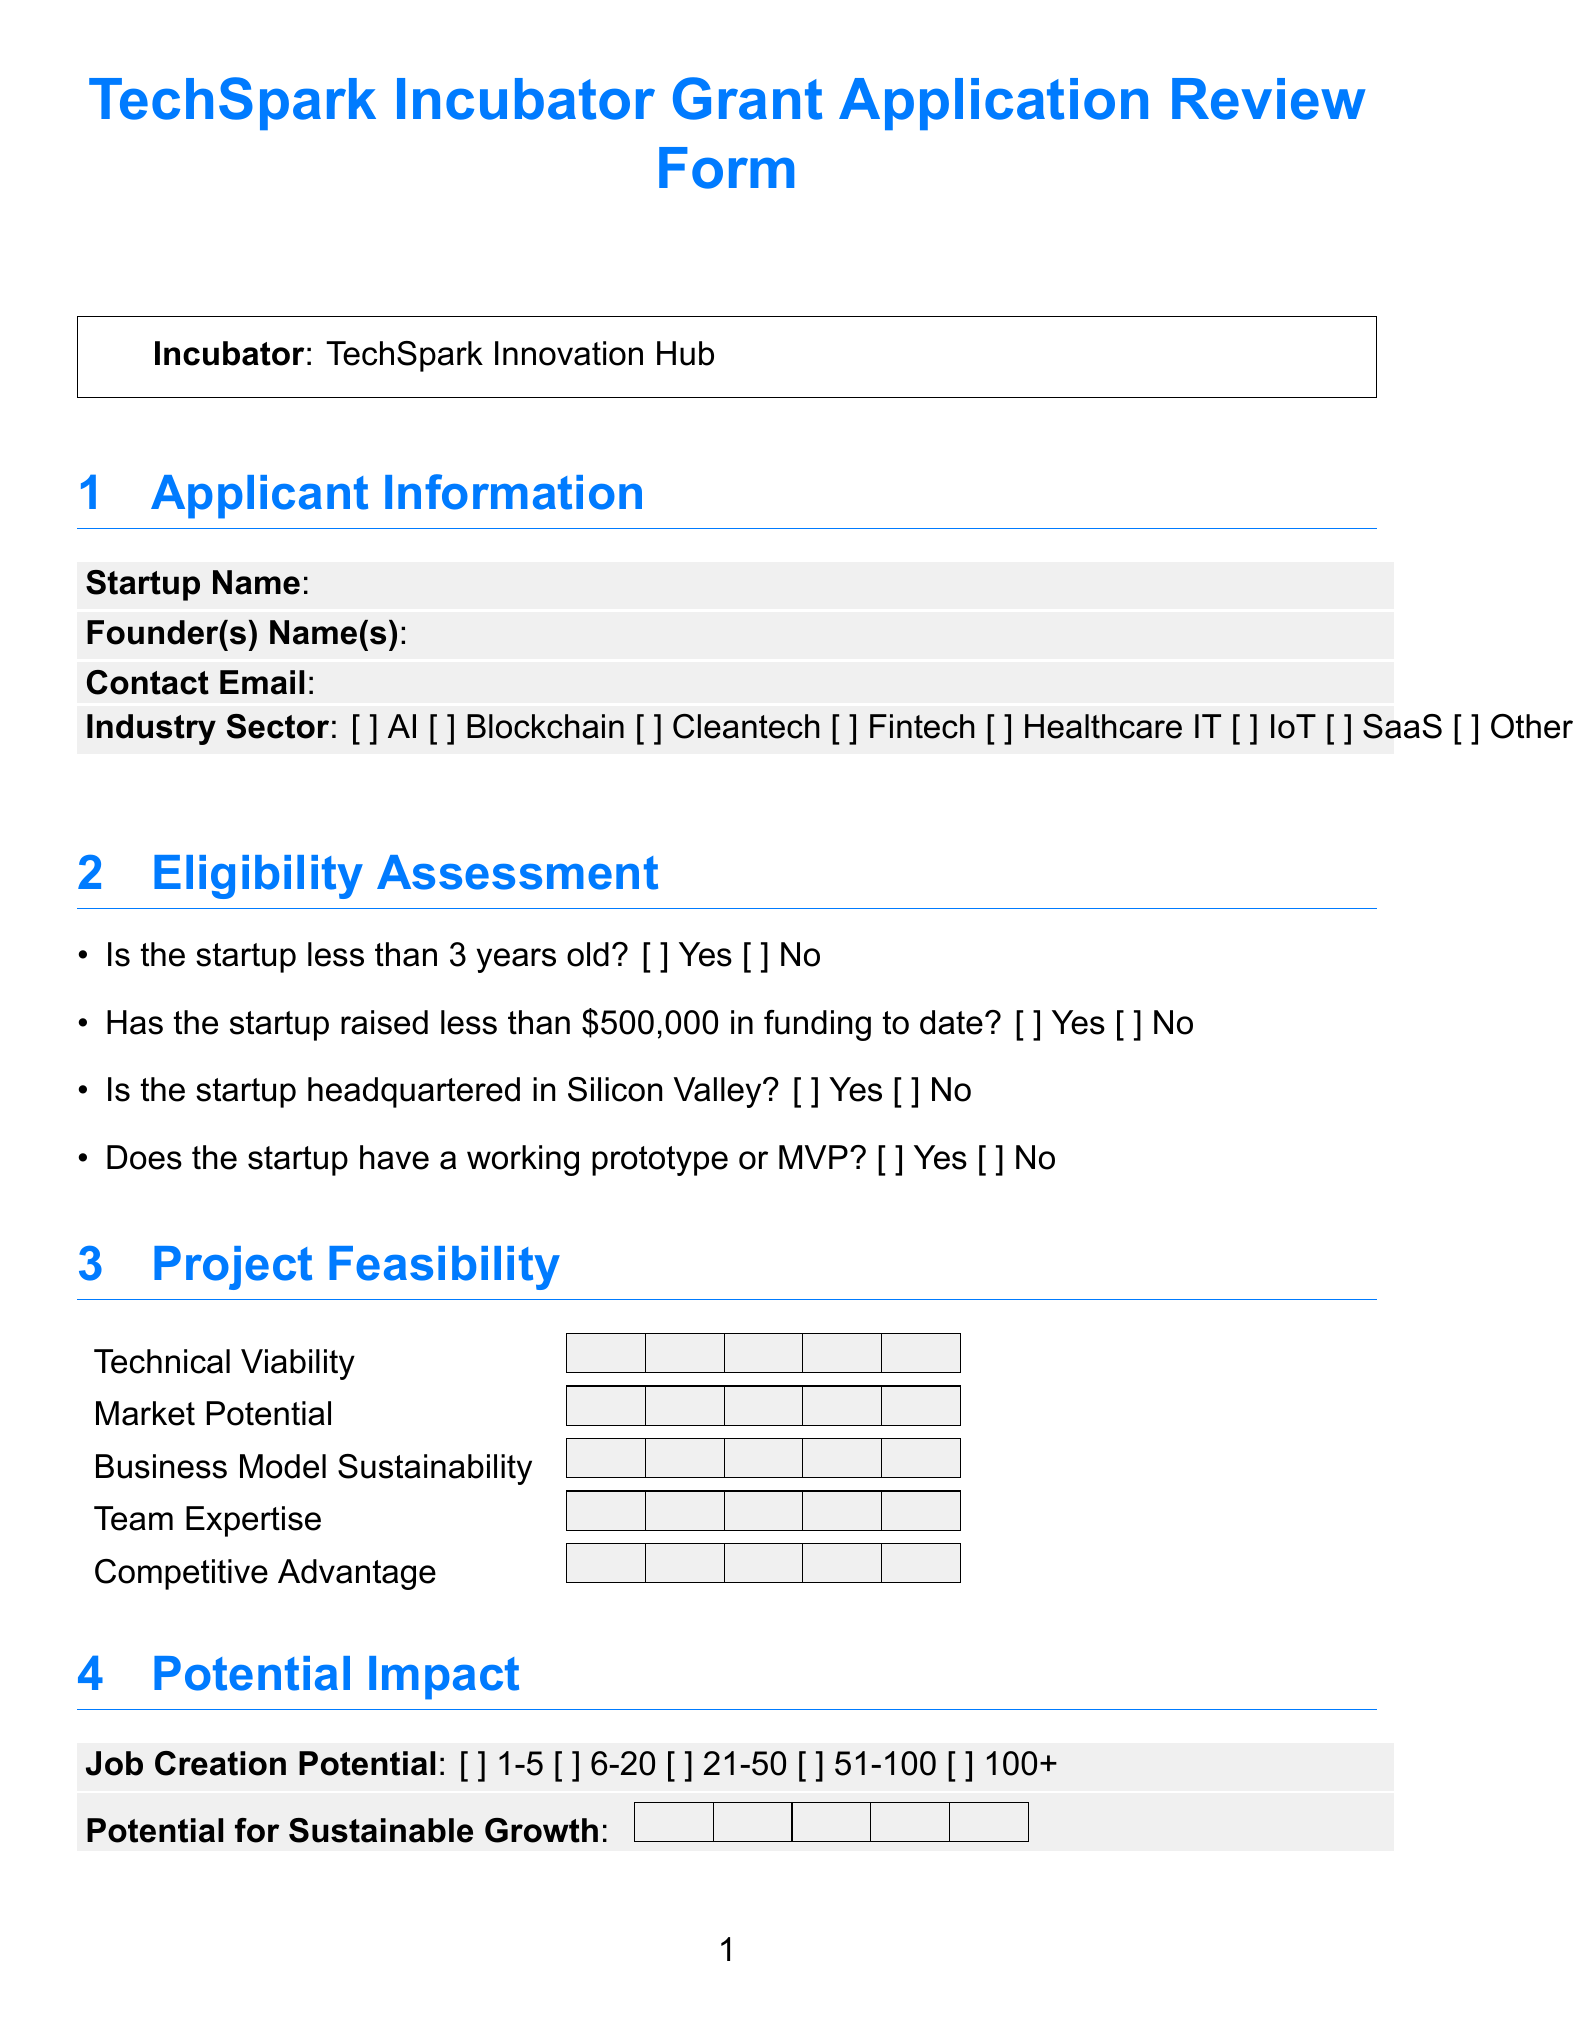What is the title of the form? The title of the form is mentioned at the beginning of the document.
Answer: TechSpark Incubator Grant Application Review Form What is the incubator name? The incubator name is given in the framed section of the document.
Answer: TechSpark Innovation Hub How many years old must a startup be to meet eligibility? The eligibility criteria specify the age of the startup.
Answer: Less than 3 years What is the maximum amount of funding a startup must have raised to date to be eligible? The eligibility section outlines funding thresholds for the startups.
Answer: Less than $500,000 What is the maximum score for the Overall Score in the Reviewer's Assessment? The rating scale for the Overall Score indicates the maximum possible rating.
Answer: 10 What is the potential job creation range for the startup? The drop-down options in the Potential Impact section provide job creation ranges.
Answer: 1-5 jobs What are the potential next steps suggested for the application? The list of suggested next steps can be found in the Reviewer's Assessment section.
Answer: Invite for pitch presentation, Request additional information, Schedule meeting with mentors, Recommend for accelerator program, Introduce to potential investors, Decline application What is the email address for submitting the form? The submission instructions specify where to send the completed form.
Answer: grants@techspark.com What rating scale is used for Team Expertise? The rating scale for Team Expertise can be found in the Project Feasibility section.
Answer: 5 